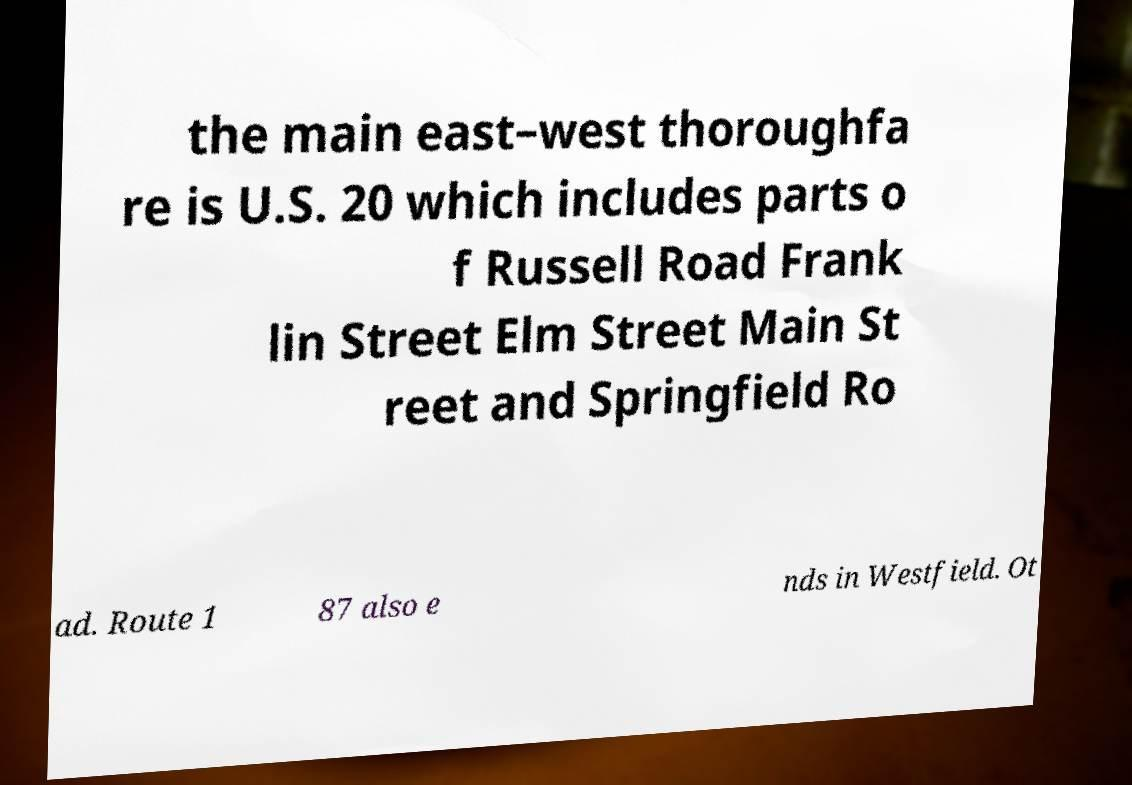Please identify and transcribe the text found in this image. the main east–west thoroughfa re is U.S. 20 which includes parts o f Russell Road Frank lin Street Elm Street Main St reet and Springfield Ro ad. Route 1 87 also e nds in Westfield. Ot 